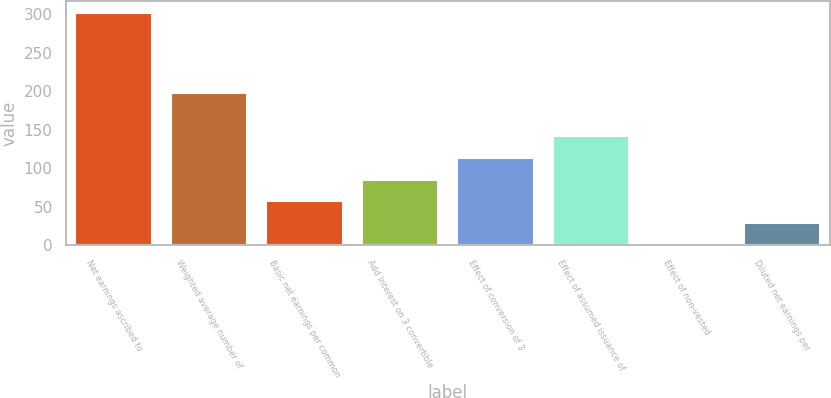<chart> <loc_0><loc_0><loc_500><loc_500><bar_chart><fcel>Net earnings ascribed to<fcel>Weighted average number of<fcel>Basic net earnings per common<fcel>Add Interest on 3 convertible<fcel>Effect of conversion of 3<fcel>Effect of assumed issuance of<fcel>Effect of non-vested<fcel>Diluted net earnings per<nl><fcel>302.21<fcel>197.57<fcel>57.02<fcel>85.13<fcel>113.24<fcel>141.35<fcel>0.8<fcel>28.91<nl></chart> 